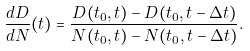<formula> <loc_0><loc_0><loc_500><loc_500>\frac { d D } { d N } ( t ) = \frac { D ( t _ { 0 } , t ) - D ( t _ { 0 } , t - \Delta t ) } { N ( t _ { 0 } , t ) - N ( t _ { 0 } , t - \Delta t ) } .</formula> 